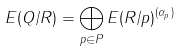Convert formula to latex. <formula><loc_0><loc_0><loc_500><loc_500>E ( Q / R ) = \bigoplus _ { p \in P } E ( R / p ) ^ { ( \alpha _ { p } ) }</formula> 